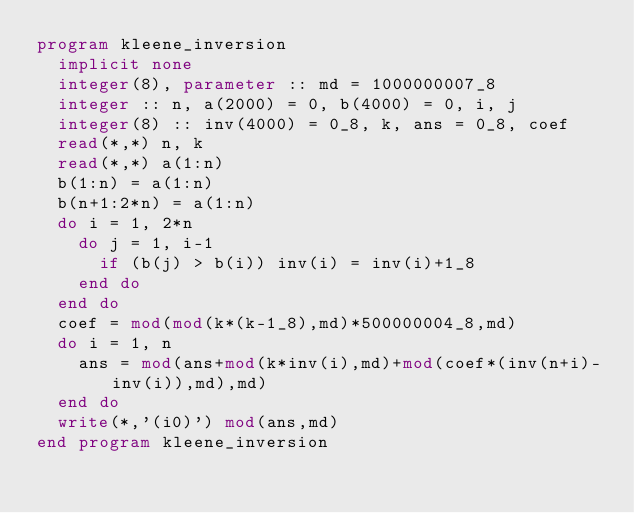Convert code to text. <code><loc_0><loc_0><loc_500><loc_500><_FORTRAN_>program kleene_inversion
  implicit none
  integer(8), parameter :: md = 1000000007_8
  integer :: n, a(2000) = 0, b(4000) = 0, i, j
  integer(8) :: inv(4000) = 0_8, k, ans = 0_8, coef
  read(*,*) n, k
  read(*,*) a(1:n)
  b(1:n) = a(1:n)
  b(n+1:2*n) = a(1:n)
  do i = 1, 2*n
    do j = 1, i-1
      if (b(j) > b(i)) inv(i) = inv(i)+1_8
    end do
  end do
  coef = mod(mod(k*(k-1_8),md)*500000004_8,md)
  do i = 1, n
    ans = mod(ans+mod(k*inv(i),md)+mod(coef*(inv(n+i)-inv(i)),md),md)
  end do
  write(*,'(i0)') mod(ans,md)
end program kleene_inversion</code> 